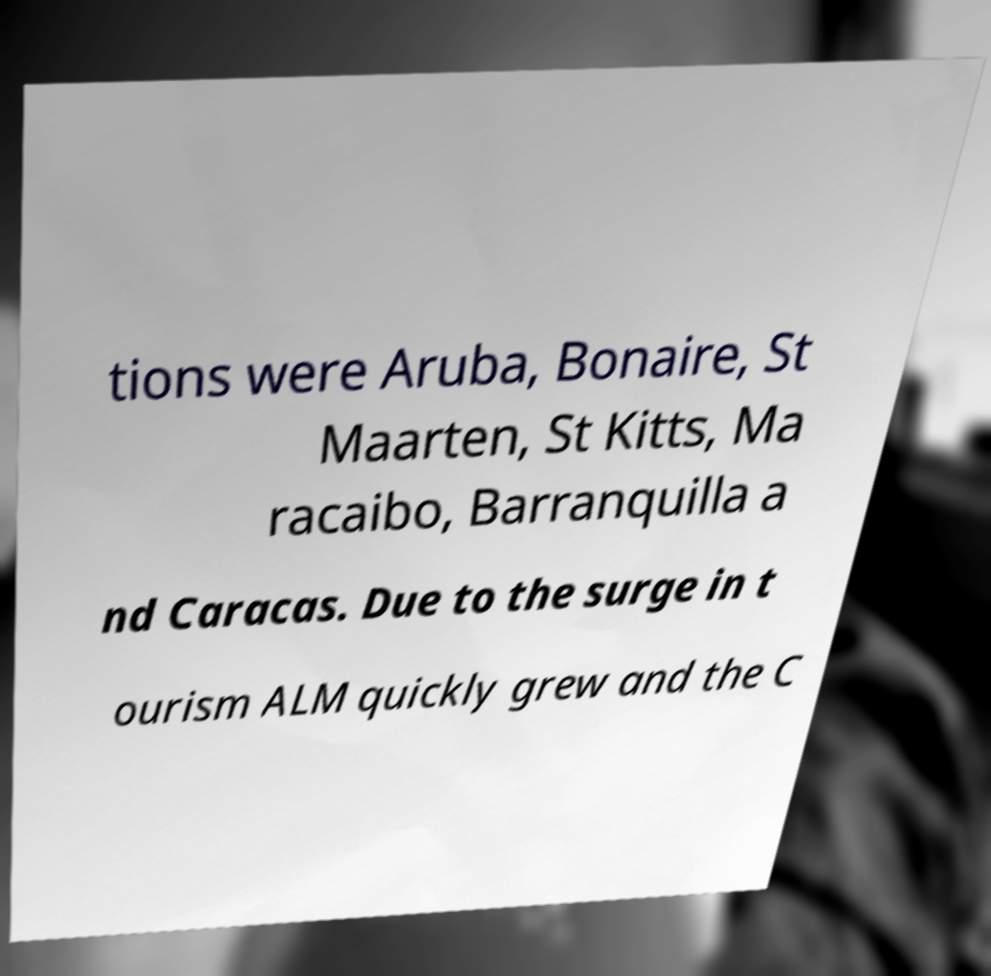For documentation purposes, I need the text within this image transcribed. Could you provide that? tions were Aruba, Bonaire, St Maarten, St Kitts, Ma racaibo, Barranquilla a nd Caracas. Due to the surge in t ourism ALM quickly grew and the C 